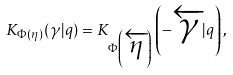Convert formula to latex. <formula><loc_0><loc_0><loc_500><loc_500>K _ { \Phi ( \eta ) } ( \gamma | q ) = K _ { \Phi \left ( \overleftarrow { \eta } \right ) } \left ( - \overleftarrow { \gamma } | q \right ) ,</formula> 